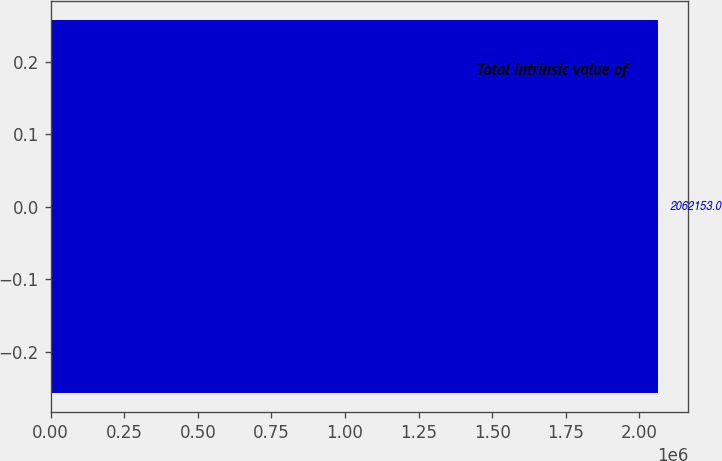<chart> <loc_0><loc_0><loc_500><loc_500><bar_chart><fcel>Total intrinsic value of<nl><fcel>2.06215e+06<nl></chart> 